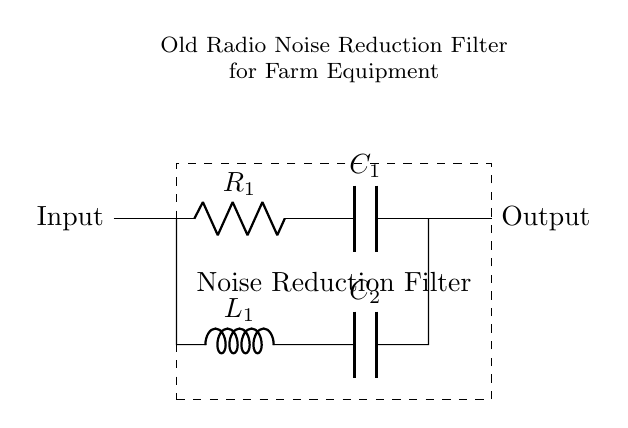What is the input of this circuit? The input is the point where the signal enters the circuit, which is labeled as "Input" in the diagram.
Answer: Input What components are used in this filter? The components in the filter are a resistor labeled R1, an inductor labeled L1, and two capacitors labeled C1 and C2.
Answer: R1, L1, C1, C2 How many capacitors are present in this circuit? There are two capacitors in the circuit, indicated by the labels C1 and C2.
Answer: 2 What is the function of the inductor in this filter circuit? The inductor is used to store energy in a magnetic field and tends to resist changes in current, thereby helping to filter out noise at certain frequencies.
Answer: Noise filtering Which component is likely to have the largest impact on high-frequency noise? Capacitor C2, as capacitors are commonly used to bypass high-frequency noise to ground, making them effective in filtering out high-frequency signals.
Answer: C2 How are the components connected in the circuit? The components are connected in a combination of series and parallel configurations, creating a complex network that helps reduce noise from the input to output.
Answer: Series and parallel What is the purpose of this circuit? The purpose of the circuit is to reduce noise in old radio equipment used on farms.
Answer: Noise reduction filter 